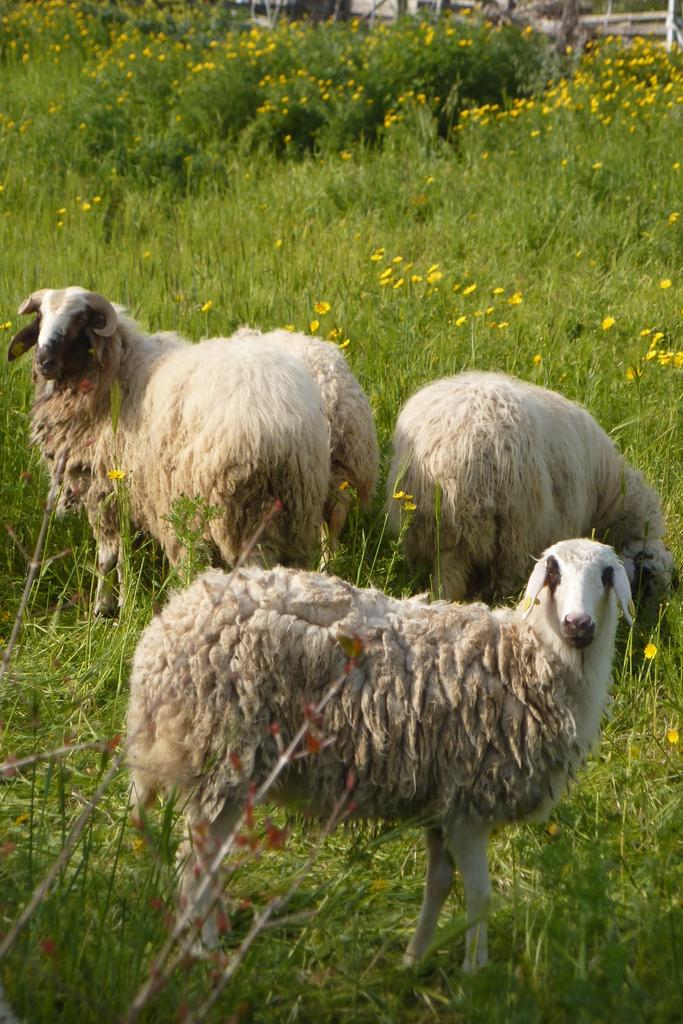How many sheep are in the image? There are three sheep in the image. What is at the bottom of the image? There is grass at the bottom of the image. What can be seen in the background of the image? There are plants and yellow flowers in the background of the image. How far away are the snails from the sheep in the image? There are no snails present in the image, so it is not possible to determine their distance from the sheep. 